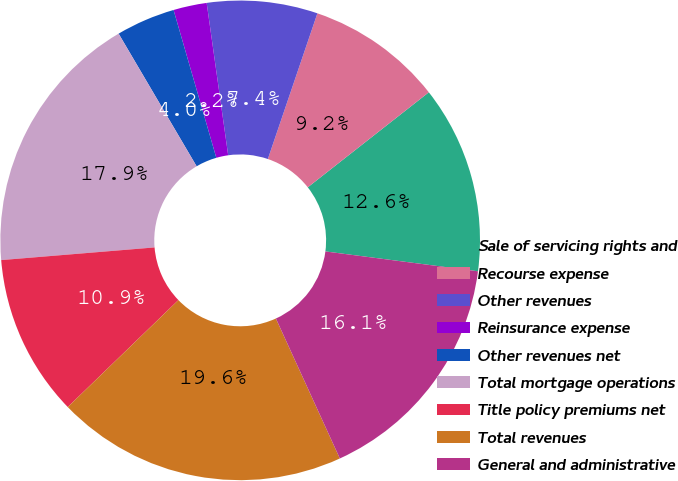Convert chart. <chart><loc_0><loc_0><loc_500><loc_500><pie_chart><fcel>Sale of servicing rights and<fcel>Recourse expense<fcel>Other revenues<fcel>Reinsurance expense<fcel>Other revenues net<fcel>Total mortgage operations<fcel>Title policy premiums net<fcel>Total revenues<fcel>General and administrative<nl><fcel>12.65%<fcel>9.19%<fcel>7.45%<fcel>2.25%<fcel>3.98%<fcel>17.85%<fcel>10.92%<fcel>19.59%<fcel>16.12%<nl></chart> 